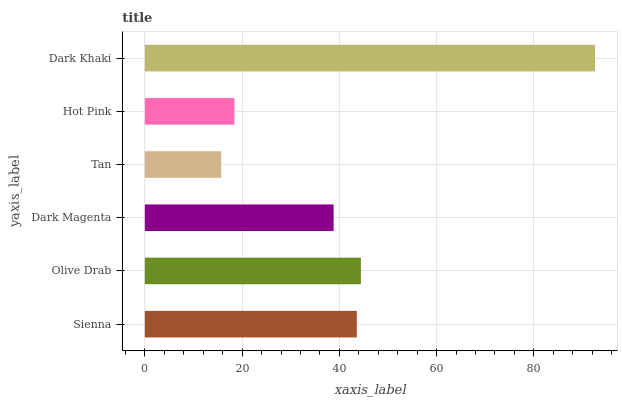Is Tan the minimum?
Answer yes or no. Yes. Is Dark Khaki the maximum?
Answer yes or no. Yes. Is Olive Drab the minimum?
Answer yes or no. No. Is Olive Drab the maximum?
Answer yes or no. No. Is Olive Drab greater than Sienna?
Answer yes or no. Yes. Is Sienna less than Olive Drab?
Answer yes or no. Yes. Is Sienna greater than Olive Drab?
Answer yes or no. No. Is Olive Drab less than Sienna?
Answer yes or no. No. Is Sienna the high median?
Answer yes or no. Yes. Is Dark Magenta the low median?
Answer yes or no. Yes. Is Tan the high median?
Answer yes or no. No. Is Sienna the low median?
Answer yes or no. No. 